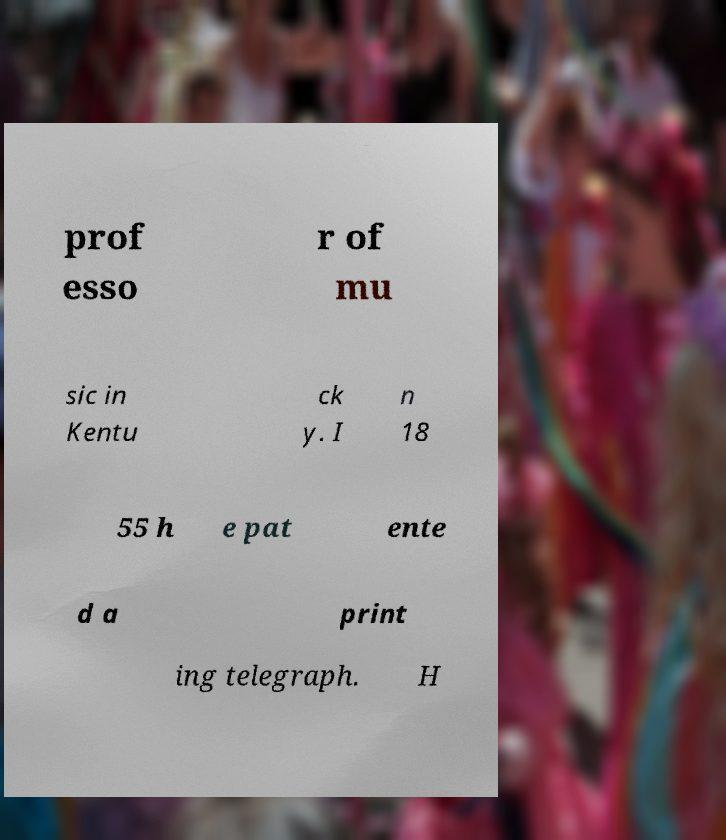Can you read and provide the text displayed in the image?This photo seems to have some interesting text. Can you extract and type it out for me? prof esso r of mu sic in Kentu ck y. I n 18 55 h e pat ente d a print ing telegraph. H 